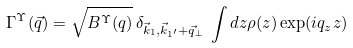<formula> <loc_0><loc_0><loc_500><loc_500>\Gamma ^ { \Upsilon } ( \vec { q } ) = \sqrt { B ^ { \Upsilon } ( q ) } \, \delta _ { \vec { k } _ { 1 } , \vec { k } _ { 1 ^ { \prime } } + \vec { q } _ { \perp } } \, \int d z \rho ( z ) \exp ( i q _ { z } z )</formula> 